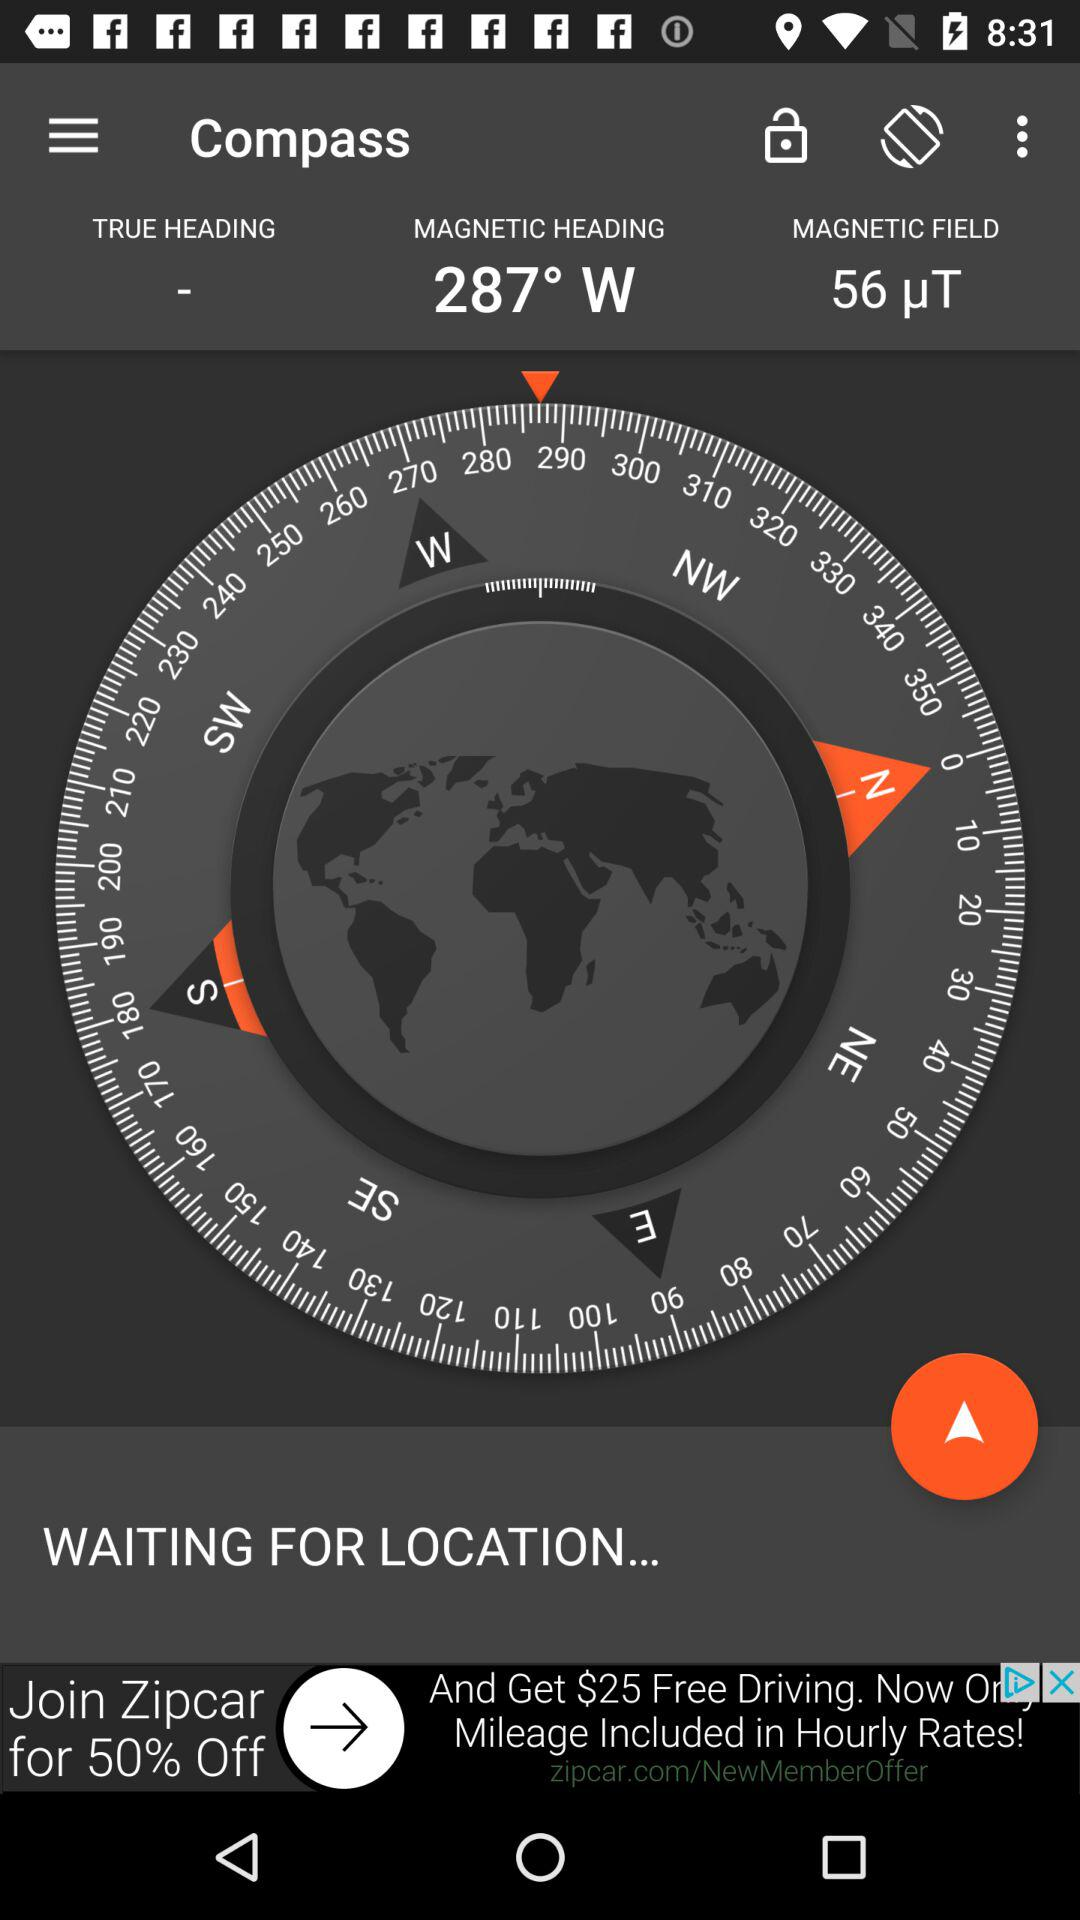What is the "MAGNETIC HEADING"? The "MAGNETIC HEADING" is 287° W. 